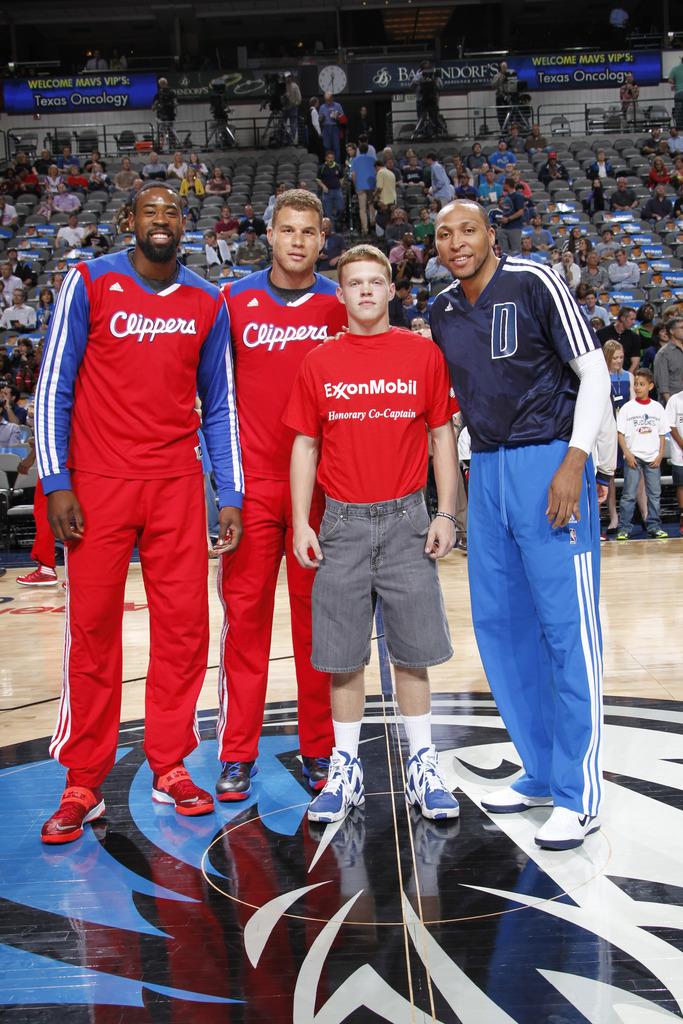What oil company is on the red tee shirt?
Your answer should be compact. Exxonmobil. 